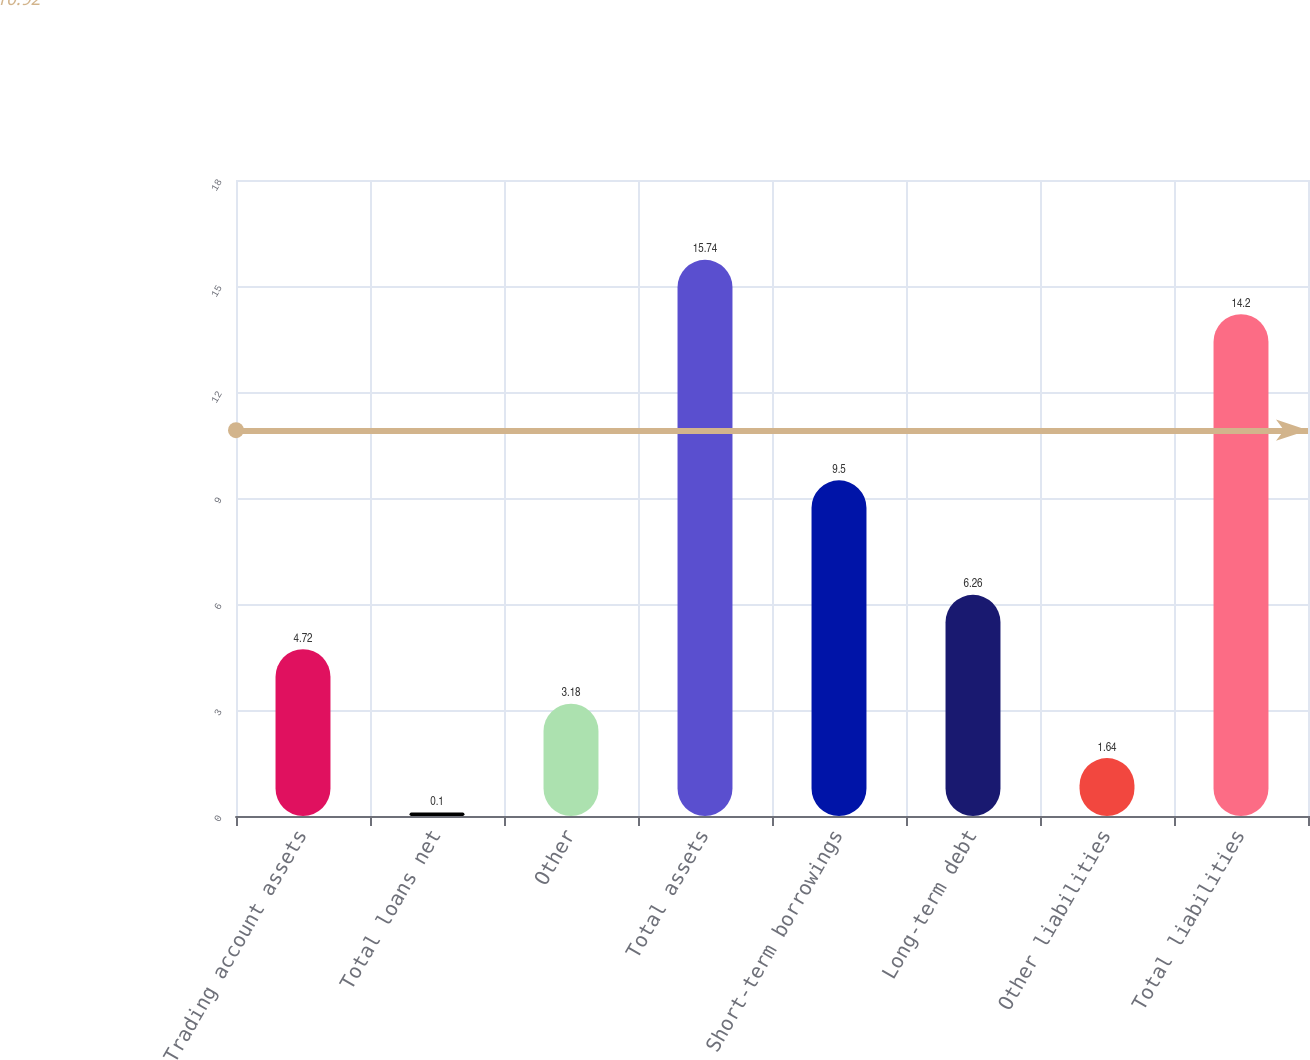Convert chart to OTSL. <chart><loc_0><loc_0><loc_500><loc_500><bar_chart><fcel>Trading account assets<fcel>Total loans net<fcel>Other<fcel>Total assets<fcel>Short-term borrowings<fcel>Long-term debt<fcel>Other liabilities<fcel>Total liabilities<nl><fcel>4.72<fcel>0.1<fcel>3.18<fcel>15.74<fcel>9.5<fcel>6.26<fcel>1.64<fcel>14.2<nl></chart> 